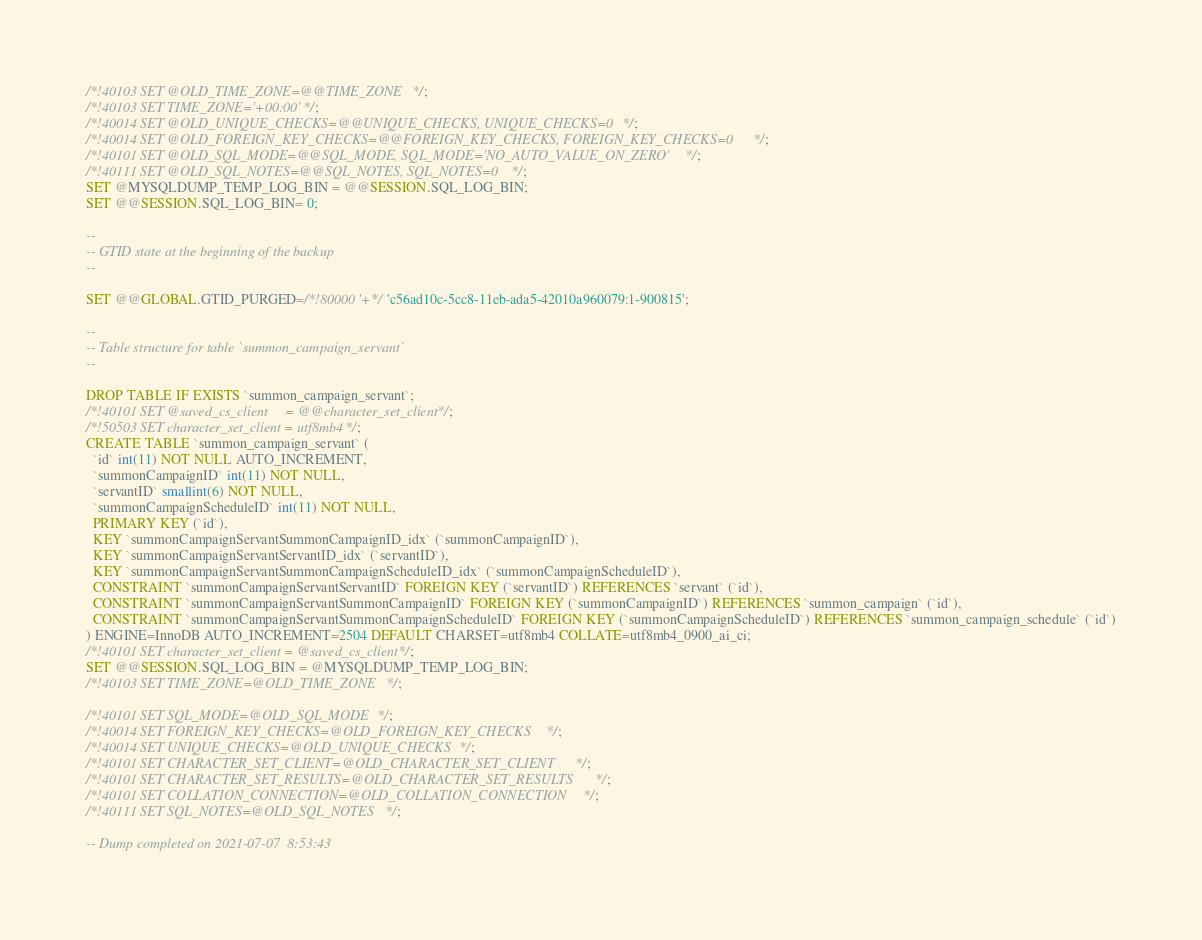<code> <loc_0><loc_0><loc_500><loc_500><_SQL_>/*!40103 SET @OLD_TIME_ZONE=@@TIME_ZONE */;
/*!40103 SET TIME_ZONE='+00:00' */;
/*!40014 SET @OLD_UNIQUE_CHECKS=@@UNIQUE_CHECKS, UNIQUE_CHECKS=0 */;
/*!40014 SET @OLD_FOREIGN_KEY_CHECKS=@@FOREIGN_KEY_CHECKS, FOREIGN_KEY_CHECKS=0 */;
/*!40101 SET @OLD_SQL_MODE=@@SQL_MODE, SQL_MODE='NO_AUTO_VALUE_ON_ZERO' */;
/*!40111 SET @OLD_SQL_NOTES=@@SQL_NOTES, SQL_NOTES=0 */;
SET @MYSQLDUMP_TEMP_LOG_BIN = @@SESSION.SQL_LOG_BIN;
SET @@SESSION.SQL_LOG_BIN= 0;

--
-- GTID state at the beginning of the backup 
--

SET @@GLOBAL.GTID_PURGED=/*!80000 '+'*/ 'c56ad10c-5cc8-11eb-ada5-42010a960079:1-900815';

--
-- Table structure for table `summon_campaign_servant`
--

DROP TABLE IF EXISTS `summon_campaign_servant`;
/*!40101 SET @saved_cs_client     = @@character_set_client */;
/*!50503 SET character_set_client = utf8mb4 */;
CREATE TABLE `summon_campaign_servant` (
  `id` int(11) NOT NULL AUTO_INCREMENT,
  `summonCampaignID` int(11) NOT NULL,
  `servantID` smallint(6) NOT NULL,
  `summonCampaignScheduleID` int(11) NOT NULL,
  PRIMARY KEY (`id`),
  KEY `summonCampaignServantSummonCampaignID_idx` (`summonCampaignID`),
  KEY `summonCampaignServantServantID_idx` (`servantID`),
  KEY `summonCampaignServantSummonCampaignScheduleID_idx` (`summonCampaignScheduleID`),
  CONSTRAINT `summonCampaignServantServantID` FOREIGN KEY (`servantID`) REFERENCES `servant` (`id`),
  CONSTRAINT `summonCampaignServantSummonCampaignID` FOREIGN KEY (`summonCampaignID`) REFERENCES `summon_campaign` (`id`),
  CONSTRAINT `summonCampaignServantSummonCampaignScheduleID` FOREIGN KEY (`summonCampaignScheduleID`) REFERENCES `summon_campaign_schedule` (`id`)
) ENGINE=InnoDB AUTO_INCREMENT=2504 DEFAULT CHARSET=utf8mb4 COLLATE=utf8mb4_0900_ai_ci;
/*!40101 SET character_set_client = @saved_cs_client */;
SET @@SESSION.SQL_LOG_BIN = @MYSQLDUMP_TEMP_LOG_BIN;
/*!40103 SET TIME_ZONE=@OLD_TIME_ZONE */;

/*!40101 SET SQL_MODE=@OLD_SQL_MODE */;
/*!40014 SET FOREIGN_KEY_CHECKS=@OLD_FOREIGN_KEY_CHECKS */;
/*!40014 SET UNIQUE_CHECKS=@OLD_UNIQUE_CHECKS */;
/*!40101 SET CHARACTER_SET_CLIENT=@OLD_CHARACTER_SET_CLIENT */;
/*!40101 SET CHARACTER_SET_RESULTS=@OLD_CHARACTER_SET_RESULTS */;
/*!40101 SET COLLATION_CONNECTION=@OLD_COLLATION_CONNECTION */;
/*!40111 SET SQL_NOTES=@OLD_SQL_NOTES */;

-- Dump completed on 2021-07-07  8:53:43
</code> 